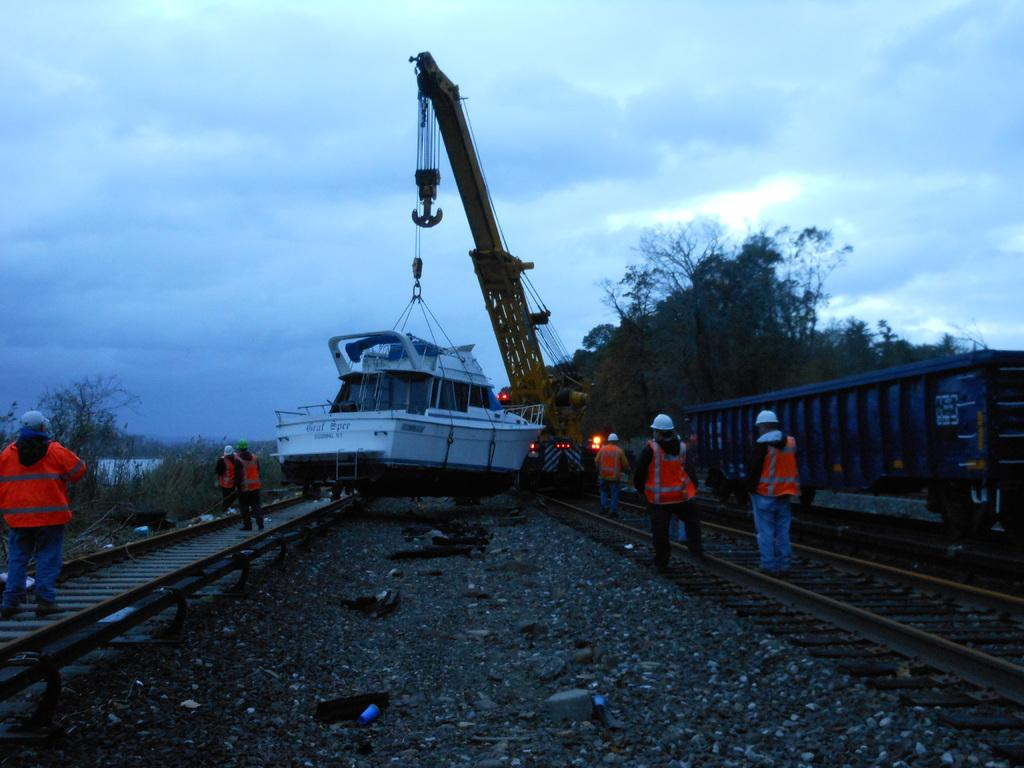What is the main subject of the image? There is a group of people standing in the image. What else can be seen in the image besides the people? There is a railway coach on the railway track, a crane, a boat, trees, and the sky is visible in the background. What type of poison is being used by the people in the image? There is no poison present in the image; it features a group of people standing near a railway coach, crane, boat, trees, and the sky. What type of cushion is being used by the people in the image? There is no cushion present in the image; it features a group of people standing near a railway coach, crane, boat, trees, and the sky. 